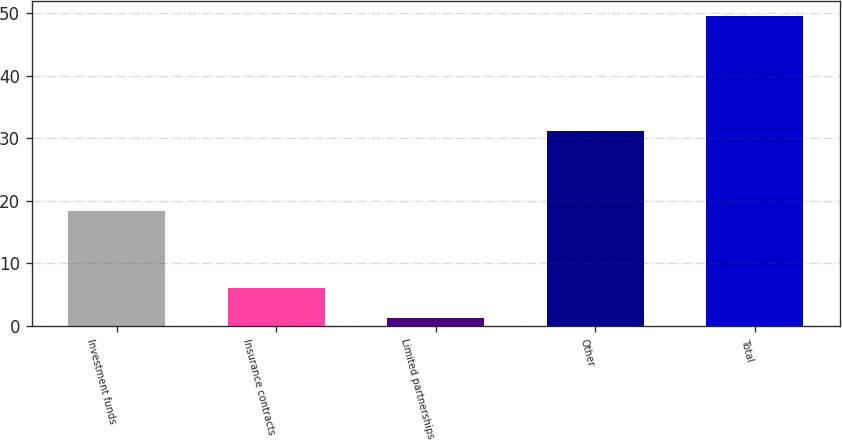Convert chart to OTSL. <chart><loc_0><loc_0><loc_500><loc_500><bar_chart><fcel>Investment funds<fcel>Insurance contracts<fcel>Limited partnerships<fcel>Other<fcel>Total<nl><fcel>18.4<fcel>6.11<fcel>1.29<fcel>31.1<fcel>49.5<nl></chart> 